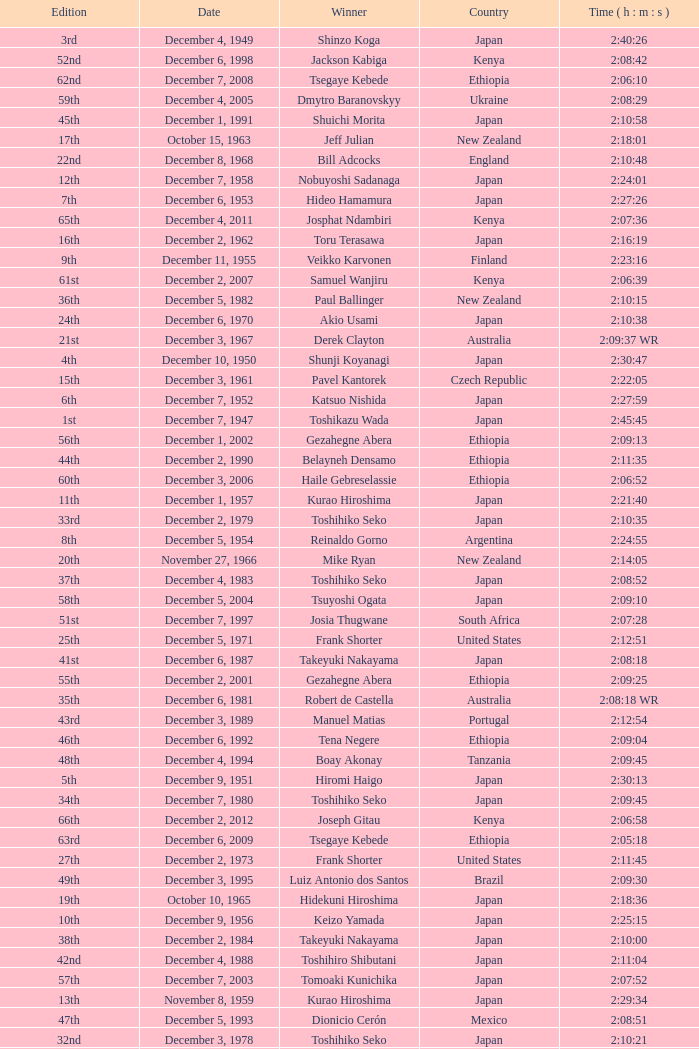Who was the winner of the 23rd Edition? Jerome Drayton. 